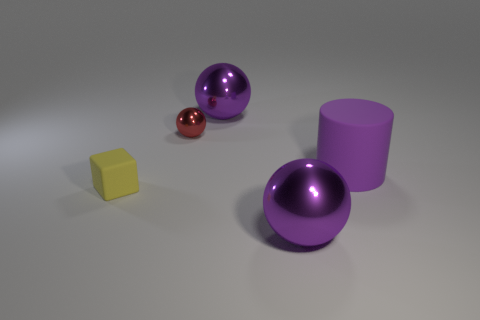Subtract all big purple spheres. How many spheres are left? 1 Add 2 small shiny objects. How many objects exist? 7 Subtract all red spheres. How many spheres are left? 2 Subtract all green blocks. How many gray cylinders are left? 0 Subtract all purple balls. Subtract all large purple metal balls. How many objects are left? 1 Add 1 tiny metal spheres. How many tiny metal spheres are left? 2 Add 4 small red balls. How many small red balls exist? 5 Subtract 0 blue cylinders. How many objects are left? 5 Subtract all blocks. How many objects are left? 4 Subtract 3 balls. How many balls are left? 0 